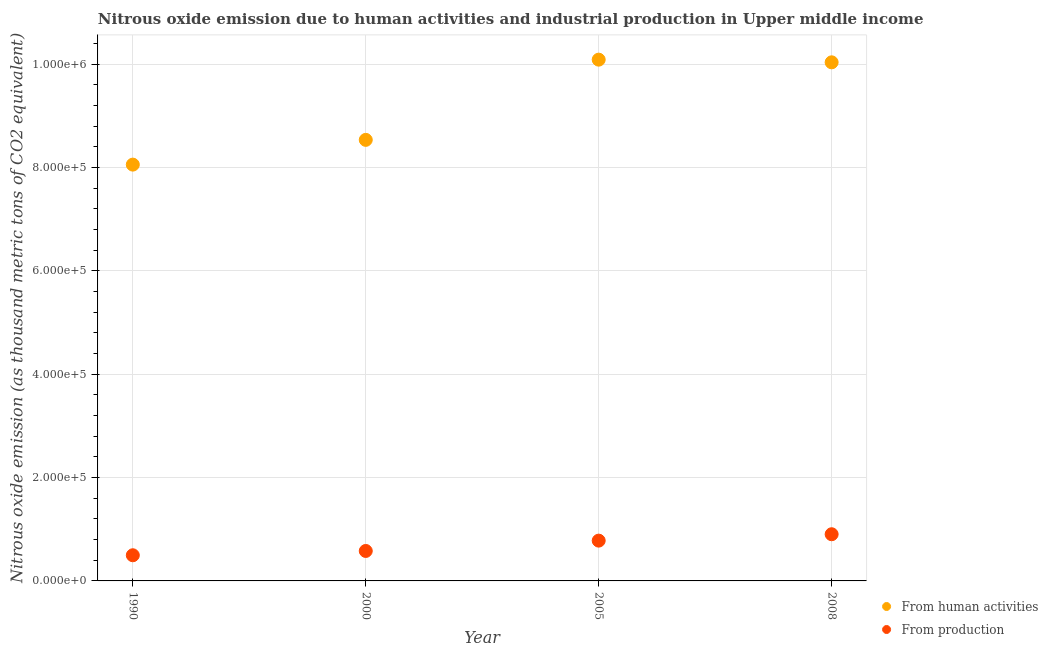Is the number of dotlines equal to the number of legend labels?
Keep it short and to the point. Yes. What is the amount of emissions generated from industries in 1990?
Provide a short and direct response. 4.97e+04. Across all years, what is the maximum amount of emissions from human activities?
Make the answer very short. 1.01e+06. Across all years, what is the minimum amount of emissions from human activities?
Provide a short and direct response. 8.06e+05. In which year was the amount of emissions generated from industries maximum?
Keep it short and to the point. 2008. What is the total amount of emissions from human activities in the graph?
Your answer should be very brief. 3.67e+06. What is the difference between the amount of emissions from human activities in 1990 and that in 2005?
Your answer should be compact. -2.03e+05. What is the difference between the amount of emissions from human activities in 2000 and the amount of emissions generated from industries in 2008?
Ensure brevity in your answer.  7.63e+05. What is the average amount of emissions generated from industries per year?
Offer a terse response. 6.90e+04. In the year 2000, what is the difference between the amount of emissions generated from industries and amount of emissions from human activities?
Your answer should be very brief. -7.96e+05. In how many years, is the amount of emissions from human activities greater than 800000 thousand metric tons?
Make the answer very short. 4. What is the ratio of the amount of emissions generated from industries in 2000 to that in 2008?
Provide a succinct answer. 0.64. Is the amount of emissions generated from industries in 2000 less than that in 2005?
Ensure brevity in your answer.  Yes. Is the difference between the amount of emissions generated from industries in 1990 and 2005 greater than the difference between the amount of emissions from human activities in 1990 and 2005?
Provide a short and direct response. Yes. What is the difference between the highest and the second highest amount of emissions generated from industries?
Provide a short and direct response. 1.24e+04. What is the difference between the highest and the lowest amount of emissions generated from industries?
Your answer should be very brief. 4.07e+04. In how many years, is the amount of emissions from human activities greater than the average amount of emissions from human activities taken over all years?
Give a very brief answer. 2. Is the sum of the amount of emissions from human activities in 2000 and 2008 greater than the maximum amount of emissions generated from industries across all years?
Offer a very short reply. Yes. Is the amount of emissions generated from industries strictly greater than the amount of emissions from human activities over the years?
Give a very brief answer. No. How many dotlines are there?
Provide a short and direct response. 2. How many years are there in the graph?
Give a very brief answer. 4. What is the difference between two consecutive major ticks on the Y-axis?
Give a very brief answer. 2.00e+05. Does the graph contain any zero values?
Give a very brief answer. No. Does the graph contain grids?
Give a very brief answer. Yes. How many legend labels are there?
Give a very brief answer. 2. How are the legend labels stacked?
Your answer should be very brief. Vertical. What is the title of the graph?
Offer a very short reply. Nitrous oxide emission due to human activities and industrial production in Upper middle income. What is the label or title of the X-axis?
Give a very brief answer. Year. What is the label or title of the Y-axis?
Your answer should be very brief. Nitrous oxide emission (as thousand metric tons of CO2 equivalent). What is the Nitrous oxide emission (as thousand metric tons of CO2 equivalent) of From human activities in 1990?
Your answer should be very brief. 8.06e+05. What is the Nitrous oxide emission (as thousand metric tons of CO2 equivalent) in From production in 1990?
Provide a short and direct response. 4.97e+04. What is the Nitrous oxide emission (as thousand metric tons of CO2 equivalent) of From human activities in 2000?
Give a very brief answer. 8.54e+05. What is the Nitrous oxide emission (as thousand metric tons of CO2 equivalent) in From production in 2000?
Keep it short and to the point. 5.80e+04. What is the Nitrous oxide emission (as thousand metric tons of CO2 equivalent) of From human activities in 2005?
Give a very brief answer. 1.01e+06. What is the Nitrous oxide emission (as thousand metric tons of CO2 equivalent) in From production in 2005?
Offer a terse response. 7.80e+04. What is the Nitrous oxide emission (as thousand metric tons of CO2 equivalent) in From human activities in 2008?
Provide a short and direct response. 1.00e+06. What is the Nitrous oxide emission (as thousand metric tons of CO2 equivalent) of From production in 2008?
Your answer should be very brief. 9.03e+04. Across all years, what is the maximum Nitrous oxide emission (as thousand metric tons of CO2 equivalent) in From human activities?
Ensure brevity in your answer.  1.01e+06. Across all years, what is the maximum Nitrous oxide emission (as thousand metric tons of CO2 equivalent) of From production?
Offer a terse response. 9.03e+04. Across all years, what is the minimum Nitrous oxide emission (as thousand metric tons of CO2 equivalent) in From human activities?
Keep it short and to the point. 8.06e+05. Across all years, what is the minimum Nitrous oxide emission (as thousand metric tons of CO2 equivalent) in From production?
Keep it short and to the point. 4.97e+04. What is the total Nitrous oxide emission (as thousand metric tons of CO2 equivalent) in From human activities in the graph?
Provide a short and direct response. 3.67e+06. What is the total Nitrous oxide emission (as thousand metric tons of CO2 equivalent) of From production in the graph?
Make the answer very short. 2.76e+05. What is the difference between the Nitrous oxide emission (as thousand metric tons of CO2 equivalent) in From human activities in 1990 and that in 2000?
Keep it short and to the point. -4.79e+04. What is the difference between the Nitrous oxide emission (as thousand metric tons of CO2 equivalent) in From production in 1990 and that in 2000?
Keep it short and to the point. -8322.4. What is the difference between the Nitrous oxide emission (as thousand metric tons of CO2 equivalent) in From human activities in 1990 and that in 2005?
Keep it short and to the point. -2.03e+05. What is the difference between the Nitrous oxide emission (as thousand metric tons of CO2 equivalent) in From production in 1990 and that in 2005?
Make the answer very short. -2.83e+04. What is the difference between the Nitrous oxide emission (as thousand metric tons of CO2 equivalent) in From human activities in 1990 and that in 2008?
Your answer should be very brief. -1.98e+05. What is the difference between the Nitrous oxide emission (as thousand metric tons of CO2 equivalent) of From production in 1990 and that in 2008?
Your answer should be compact. -4.07e+04. What is the difference between the Nitrous oxide emission (as thousand metric tons of CO2 equivalent) of From human activities in 2000 and that in 2005?
Keep it short and to the point. -1.55e+05. What is the difference between the Nitrous oxide emission (as thousand metric tons of CO2 equivalent) in From production in 2000 and that in 2005?
Keep it short and to the point. -2.00e+04. What is the difference between the Nitrous oxide emission (as thousand metric tons of CO2 equivalent) of From human activities in 2000 and that in 2008?
Your response must be concise. -1.50e+05. What is the difference between the Nitrous oxide emission (as thousand metric tons of CO2 equivalent) in From production in 2000 and that in 2008?
Provide a succinct answer. -3.24e+04. What is the difference between the Nitrous oxide emission (as thousand metric tons of CO2 equivalent) in From human activities in 2005 and that in 2008?
Keep it short and to the point. 5159.9. What is the difference between the Nitrous oxide emission (as thousand metric tons of CO2 equivalent) in From production in 2005 and that in 2008?
Give a very brief answer. -1.24e+04. What is the difference between the Nitrous oxide emission (as thousand metric tons of CO2 equivalent) in From human activities in 1990 and the Nitrous oxide emission (as thousand metric tons of CO2 equivalent) in From production in 2000?
Offer a terse response. 7.48e+05. What is the difference between the Nitrous oxide emission (as thousand metric tons of CO2 equivalent) of From human activities in 1990 and the Nitrous oxide emission (as thousand metric tons of CO2 equivalent) of From production in 2005?
Ensure brevity in your answer.  7.28e+05. What is the difference between the Nitrous oxide emission (as thousand metric tons of CO2 equivalent) in From human activities in 1990 and the Nitrous oxide emission (as thousand metric tons of CO2 equivalent) in From production in 2008?
Make the answer very short. 7.15e+05. What is the difference between the Nitrous oxide emission (as thousand metric tons of CO2 equivalent) in From human activities in 2000 and the Nitrous oxide emission (as thousand metric tons of CO2 equivalent) in From production in 2005?
Your response must be concise. 7.76e+05. What is the difference between the Nitrous oxide emission (as thousand metric tons of CO2 equivalent) of From human activities in 2000 and the Nitrous oxide emission (as thousand metric tons of CO2 equivalent) of From production in 2008?
Make the answer very short. 7.63e+05. What is the difference between the Nitrous oxide emission (as thousand metric tons of CO2 equivalent) of From human activities in 2005 and the Nitrous oxide emission (as thousand metric tons of CO2 equivalent) of From production in 2008?
Provide a succinct answer. 9.18e+05. What is the average Nitrous oxide emission (as thousand metric tons of CO2 equivalent) of From human activities per year?
Give a very brief answer. 9.18e+05. What is the average Nitrous oxide emission (as thousand metric tons of CO2 equivalent) of From production per year?
Ensure brevity in your answer.  6.90e+04. In the year 1990, what is the difference between the Nitrous oxide emission (as thousand metric tons of CO2 equivalent) in From human activities and Nitrous oxide emission (as thousand metric tons of CO2 equivalent) in From production?
Ensure brevity in your answer.  7.56e+05. In the year 2000, what is the difference between the Nitrous oxide emission (as thousand metric tons of CO2 equivalent) of From human activities and Nitrous oxide emission (as thousand metric tons of CO2 equivalent) of From production?
Ensure brevity in your answer.  7.96e+05. In the year 2005, what is the difference between the Nitrous oxide emission (as thousand metric tons of CO2 equivalent) of From human activities and Nitrous oxide emission (as thousand metric tons of CO2 equivalent) of From production?
Offer a terse response. 9.31e+05. In the year 2008, what is the difference between the Nitrous oxide emission (as thousand metric tons of CO2 equivalent) in From human activities and Nitrous oxide emission (as thousand metric tons of CO2 equivalent) in From production?
Your answer should be compact. 9.13e+05. What is the ratio of the Nitrous oxide emission (as thousand metric tons of CO2 equivalent) in From human activities in 1990 to that in 2000?
Ensure brevity in your answer.  0.94. What is the ratio of the Nitrous oxide emission (as thousand metric tons of CO2 equivalent) of From production in 1990 to that in 2000?
Make the answer very short. 0.86. What is the ratio of the Nitrous oxide emission (as thousand metric tons of CO2 equivalent) in From human activities in 1990 to that in 2005?
Keep it short and to the point. 0.8. What is the ratio of the Nitrous oxide emission (as thousand metric tons of CO2 equivalent) in From production in 1990 to that in 2005?
Your response must be concise. 0.64. What is the ratio of the Nitrous oxide emission (as thousand metric tons of CO2 equivalent) of From human activities in 1990 to that in 2008?
Offer a terse response. 0.8. What is the ratio of the Nitrous oxide emission (as thousand metric tons of CO2 equivalent) in From production in 1990 to that in 2008?
Your answer should be very brief. 0.55. What is the ratio of the Nitrous oxide emission (as thousand metric tons of CO2 equivalent) in From human activities in 2000 to that in 2005?
Provide a succinct answer. 0.85. What is the ratio of the Nitrous oxide emission (as thousand metric tons of CO2 equivalent) of From production in 2000 to that in 2005?
Make the answer very short. 0.74. What is the ratio of the Nitrous oxide emission (as thousand metric tons of CO2 equivalent) in From human activities in 2000 to that in 2008?
Your answer should be very brief. 0.85. What is the ratio of the Nitrous oxide emission (as thousand metric tons of CO2 equivalent) of From production in 2000 to that in 2008?
Give a very brief answer. 0.64. What is the ratio of the Nitrous oxide emission (as thousand metric tons of CO2 equivalent) of From human activities in 2005 to that in 2008?
Ensure brevity in your answer.  1.01. What is the ratio of the Nitrous oxide emission (as thousand metric tons of CO2 equivalent) of From production in 2005 to that in 2008?
Offer a very short reply. 0.86. What is the difference between the highest and the second highest Nitrous oxide emission (as thousand metric tons of CO2 equivalent) of From human activities?
Provide a succinct answer. 5159.9. What is the difference between the highest and the second highest Nitrous oxide emission (as thousand metric tons of CO2 equivalent) in From production?
Keep it short and to the point. 1.24e+04. What is the difference between the highest and the lowest Nitrous oxide emission (as thousand metric tons of CO2 equivalent) in From human activities?
Give a very brief answer. 2.03e+05. What is the difference between the highest and the lowest Nitrous oxide emission (as thousand metric tons of CO2 equivalent) of From production?
Make the answer very short. 4.07e+04. 